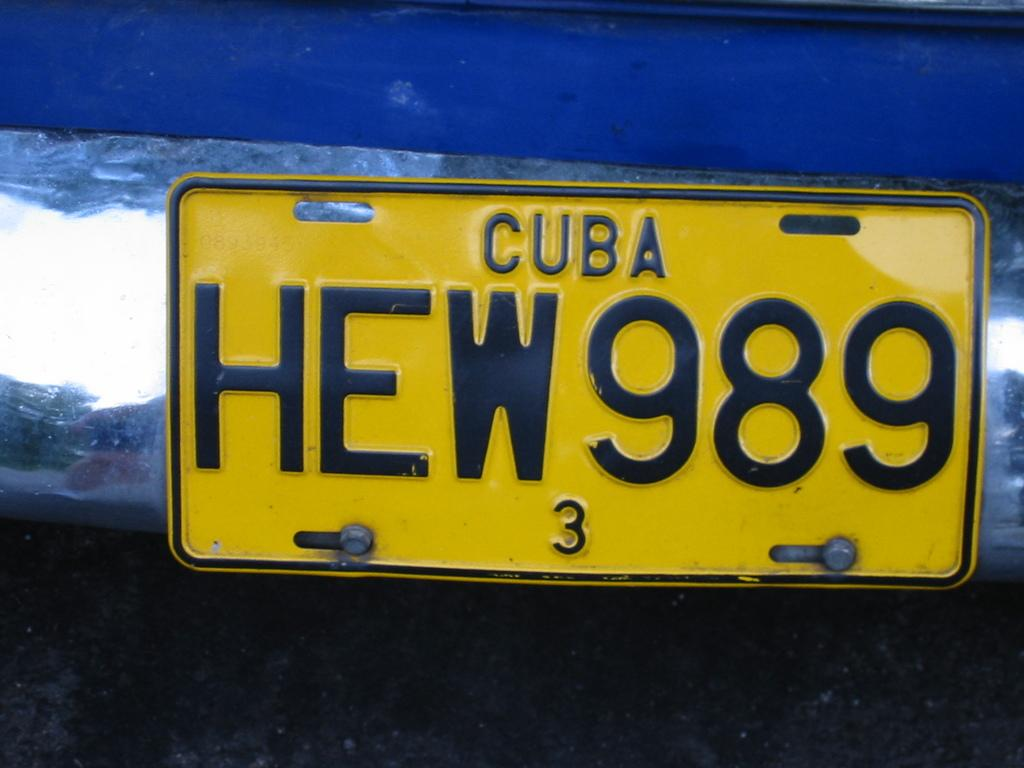Provide a one-sentence caption for the provided image. A blue vehicle from Cuba has the license plate number HEW989. 